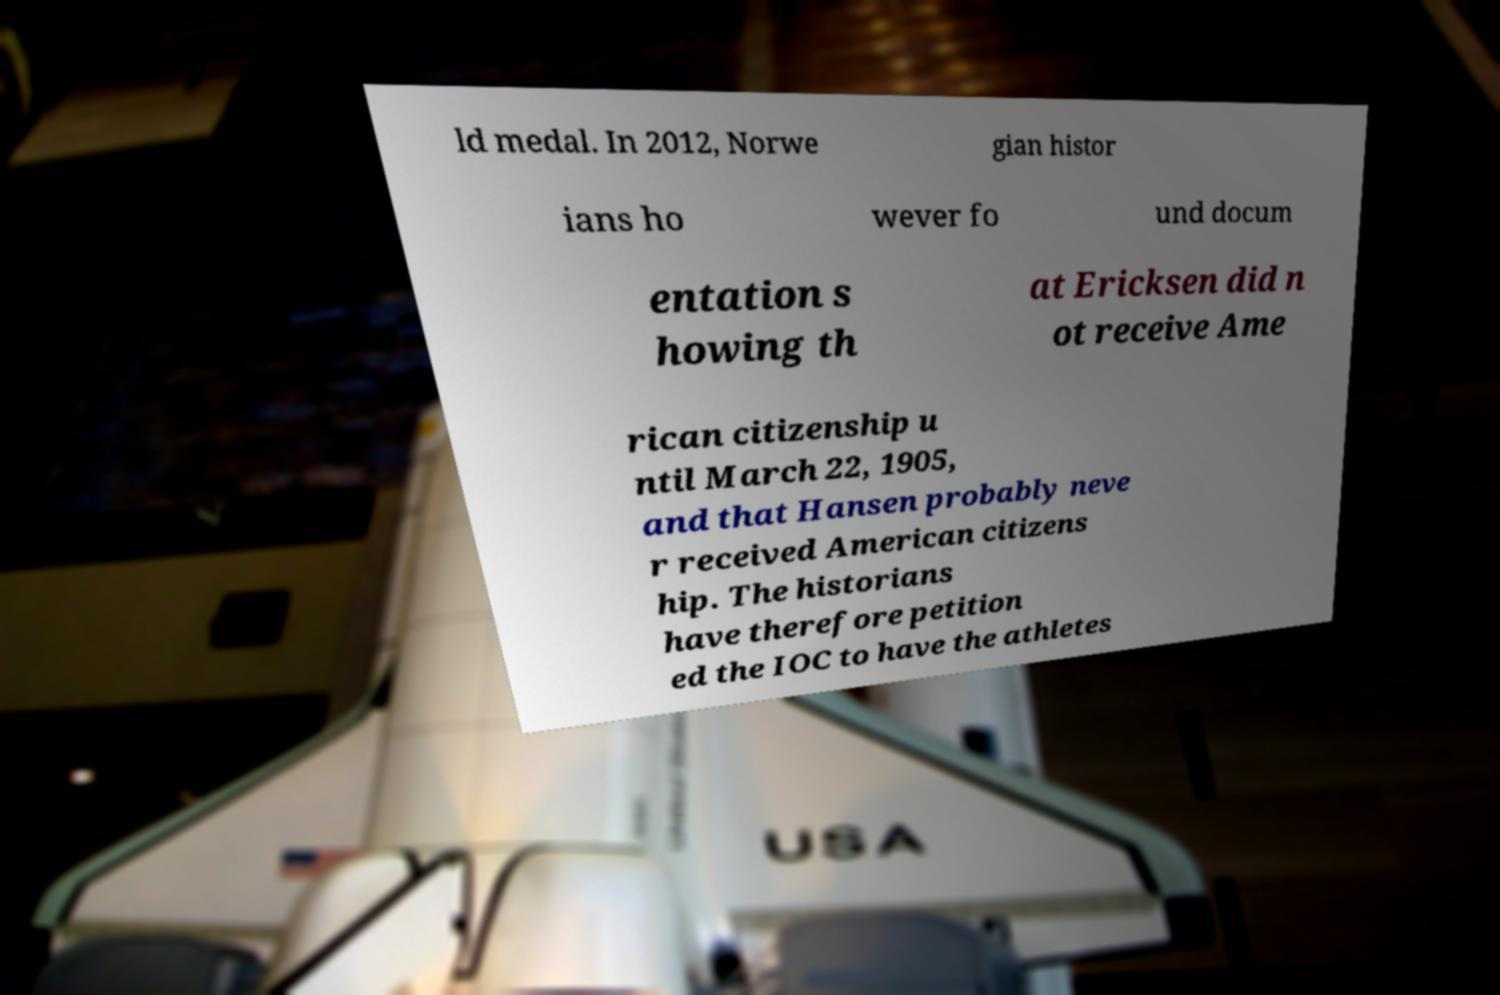There's text embedded in this image that I need extracted. Can you transcribe it verbatim? ld medal. In 2012, Norwe gian histor ians ho wever fo und docum entation s howing th at Ericksen did n ot receive Ame rican citizenship u ntil March 22, 1905, and that Hansen probably neve r received American citizens hip. The historians have therefore petition ed the IOC to have the athletes 